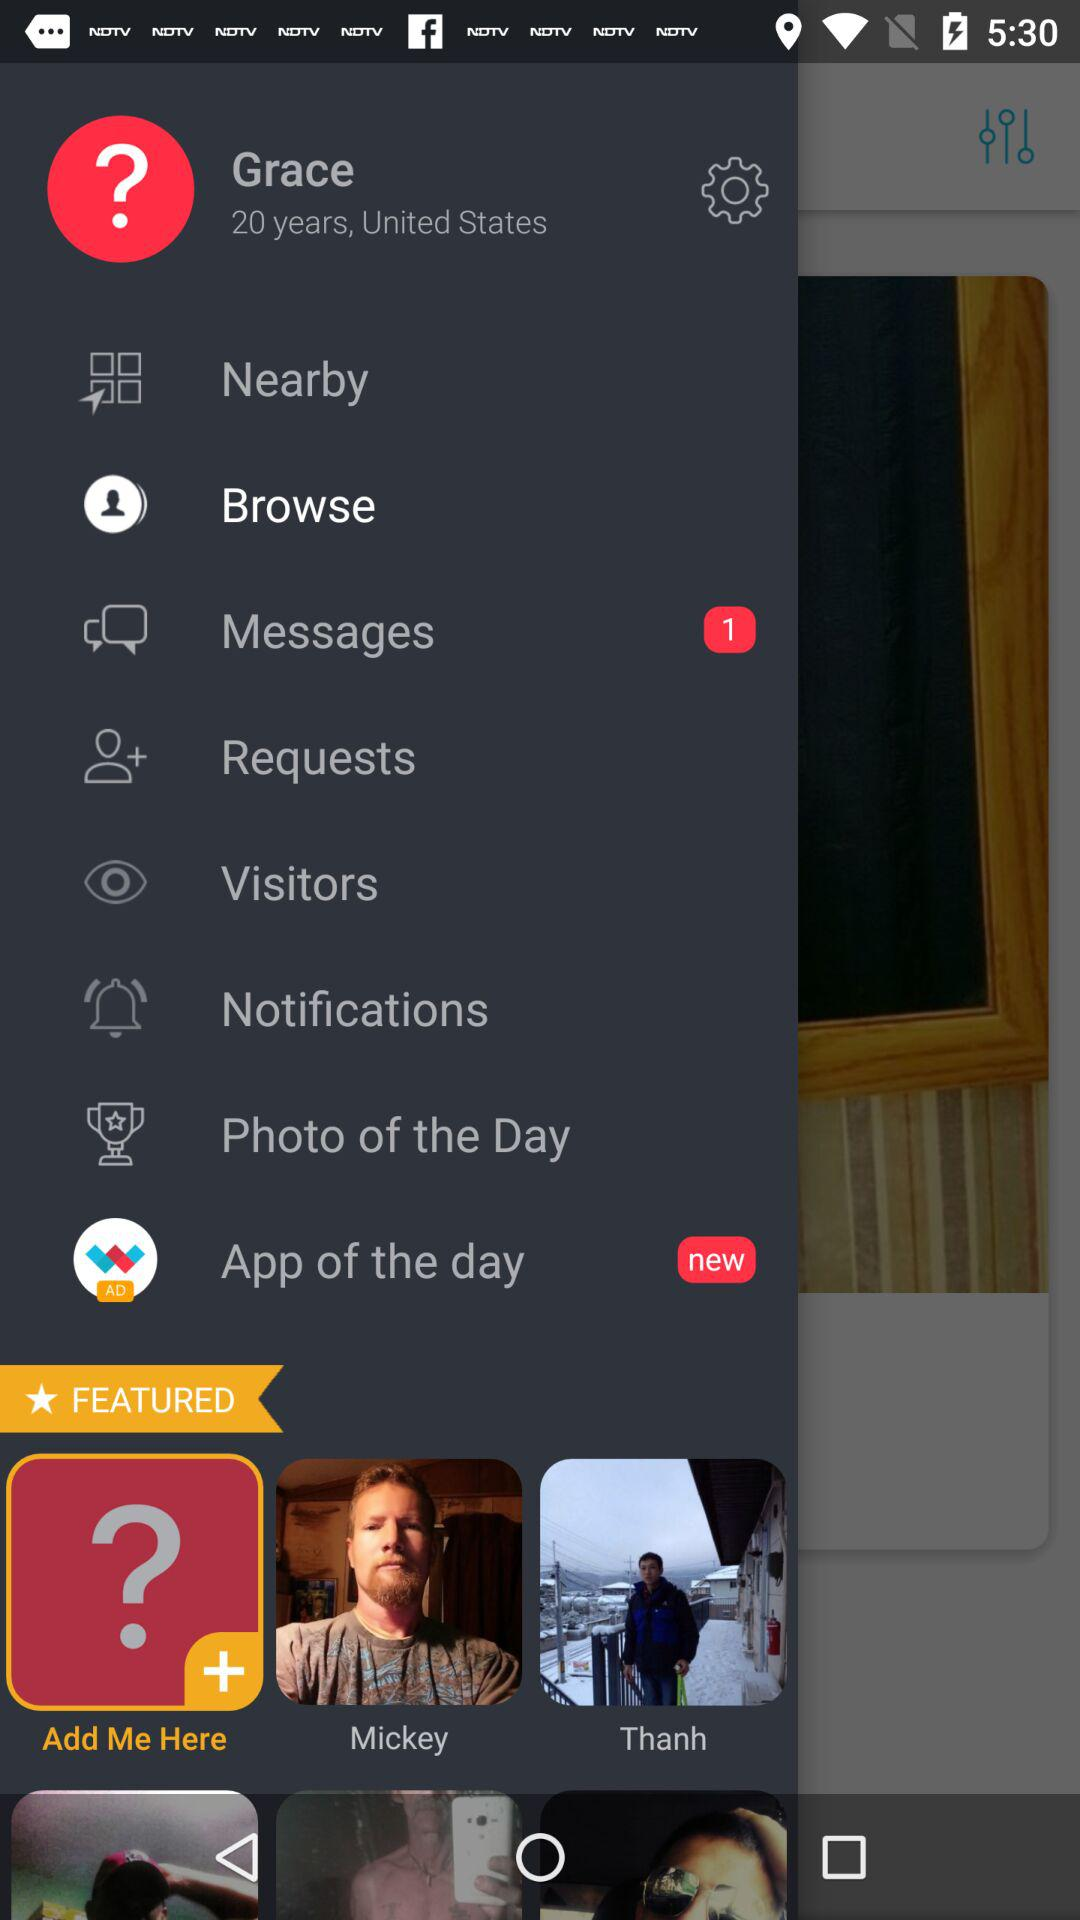How many messages are pending to be read? There is 1 pending message. 